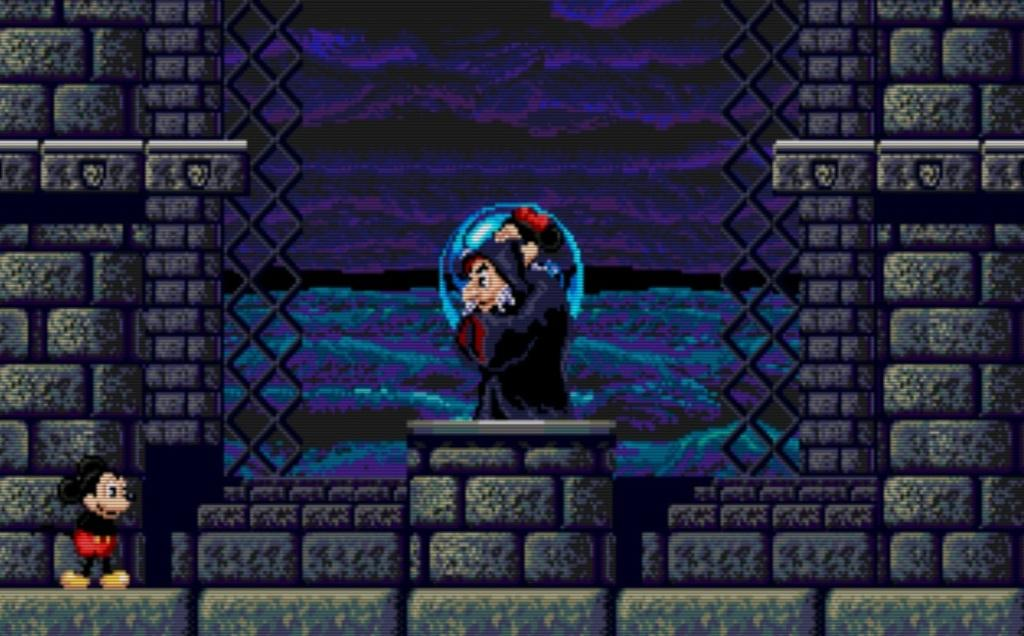What type of image is being described? The image is an animation. What character can be seen on the floor in the image? There is a Mickey Mouse character on the floor. Where is the person in the image located? The person is standing on a pillar in the middle of the image. How many trees are visible in the image? There are no trees visible in the image, as it is an animation featuring a Mickey Mouse character and a person standing on a pillar. 